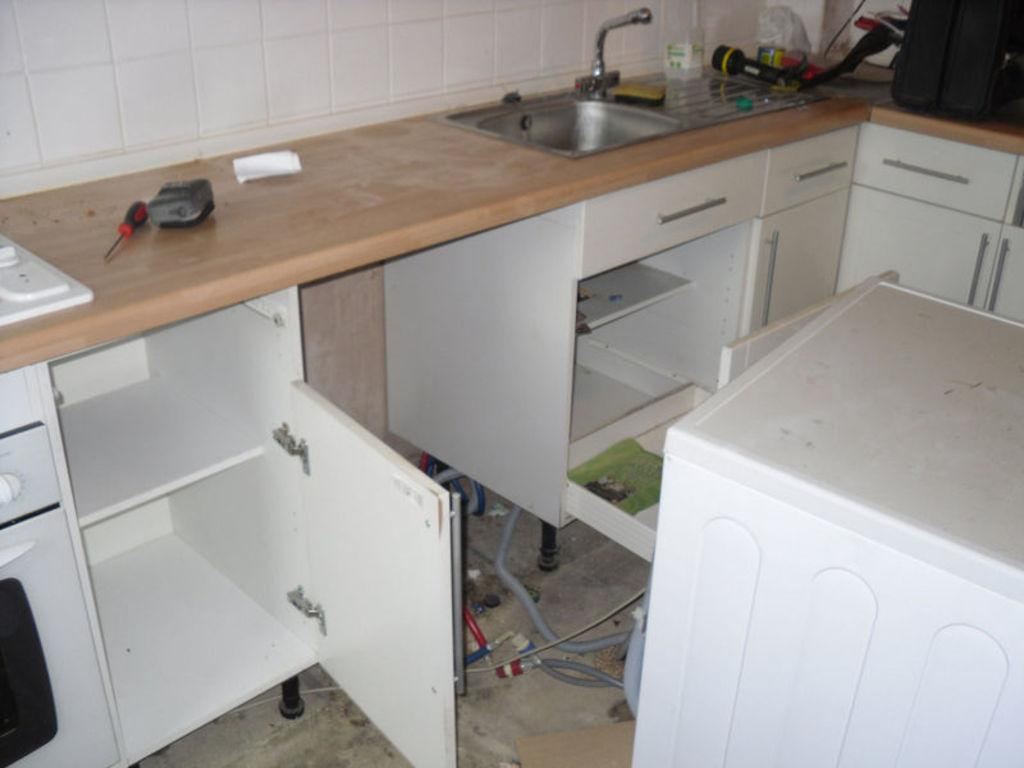What type of table is in the image? There is a wooden table in the image. What can be found on the table? There are objects on the table. What is located near the table? There is a sink in the image. What is attached to the sink? There is a tap in the image. What type of storage is present in the image? There are cupboards in the image. What is the background of the image made of? There is a wall in the image. What type of dress is hanging on the wall in the image? There is no dress present in the image; the wall is a background element and does not have any clothing items hanging on it. 